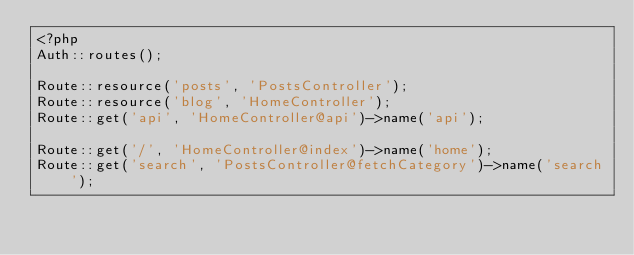<code> <loc_0><loc_0><loc_500><loc_500><_PHP_><?php
Auth::routes();

Route::resource('posts', 'PostsController');
Route::resource('blog', 'HomeController');
Route::get('api', 'HomeController@api')->name('api');

Route::get('/', 'HomeController@index')->name('home');
Route::get('search', 'PostsController@fetchCategory')->name('search');
</code> 